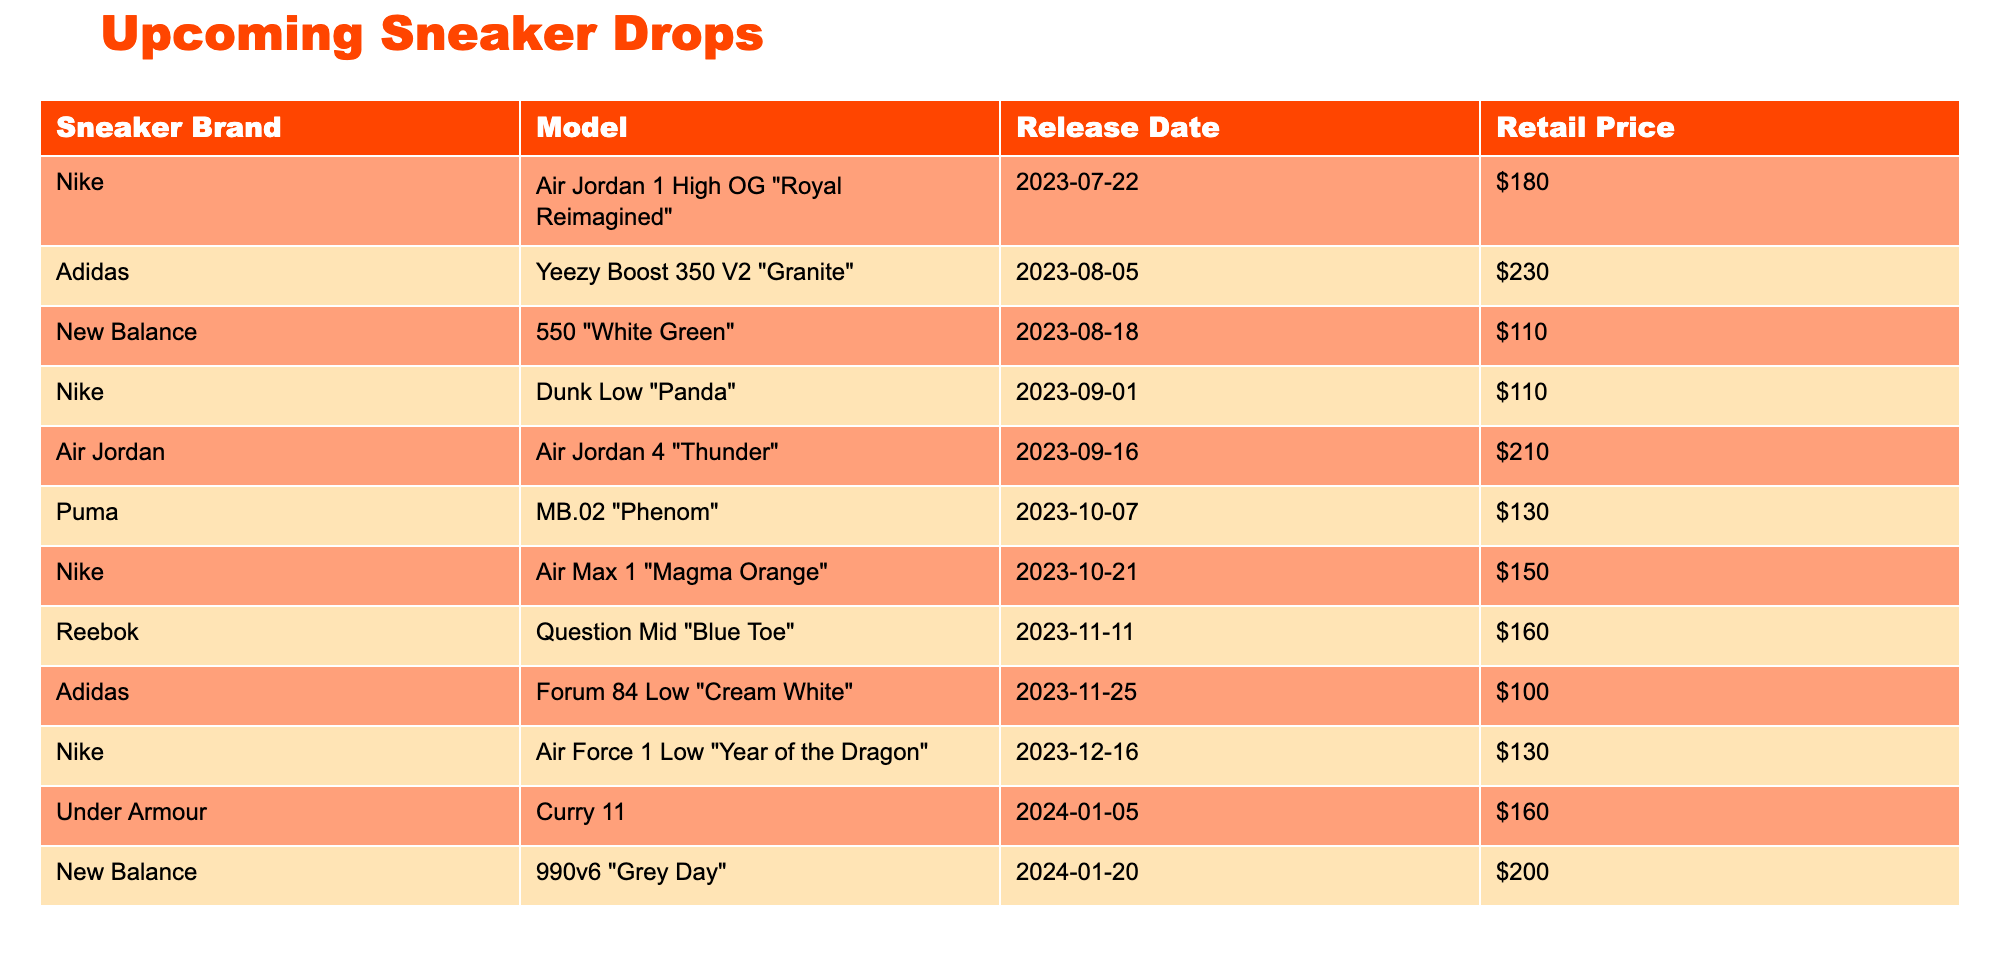What is the retail price of the Yeezy Boost 350 V2 "Granite"? The table shows the sneaker model Yeezy Boost 350 V2 "Granite" from Adidas, with a corresponding retail price listed in the same row. The retail price is $230.
Answer: $230 Which sneaker has the highest retail price among the listed drops? To find the highest retail price, we can compare the prices of all sneakers in the table. By checking each price, we see that the Air Jordan 4 "Thunder" has the highest price at $210.
Answer: Air Jordan 4 "Thunder" How many sneakers are priced at $130? We can scan the table for sneakers that are listed with the retail price of $130. The models that match this price are the Puma MB.02 "Phenom" and the Nike Air Force 1 Low "Year of the Dragon", making a total of 2 sneakers.
Answer: 2 What is the average retail price of all the sneakers listed in the table? First, we sum the retail prices of each sneaker: 180 + 230 + 110 + 110 + 210 + 130 + 150 + 160 + 100 + 130 + 160 + 200 = 1,490. The total number of sneakers is 12. Therefore, the average price is 1,490 / 12 = approximately $124.17.
Answer: $124.17 Is the release date for the Air Jordan 1 High OG "Royal Reimagined" before or after the release date for the New Balance 550 "White Green"? We check the release dates in the table. The Air Jordan 1 High OG "Royal Reimagined" is set for release on July 22, 2023, which is before the New Balance 550 "White Green" that releases on August 18, 2023.
Answer: Before 